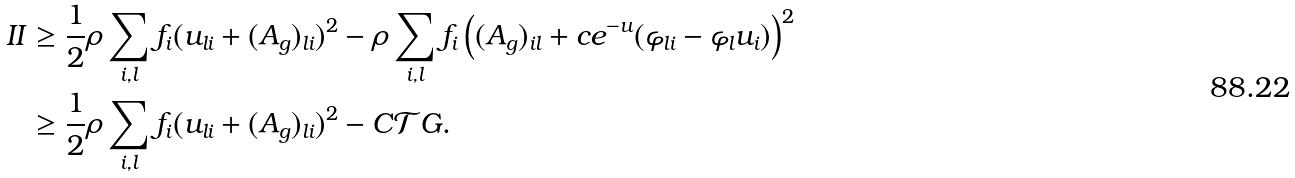<formula> <loc_0><loc_0><loc_500><loc_500>I I & \geq \frac { 1 } { 2 } \rho \sum _ { i , l } f _ { i } ( u _ { l i } + ( A _ { g } ) _ { l i } ) ^ { 2 } - \rho \sum _ { i , l } f _ { i } \left ( ( A _ { g } ) _ { i l } + c e ^ { - u } ( \varphi _ { l i } - \varphi _ { l } u _ { i } ) \right ) ^ { 2 } \\ & \geq \frac { 1 } { 2 } \rho \sum _ { i , l } f _ { i } ( u _ { l i } + ( A _ { g } ) _ { l i } ) ^ { 2 } - C { \mathcal { T } } G .</formula> 